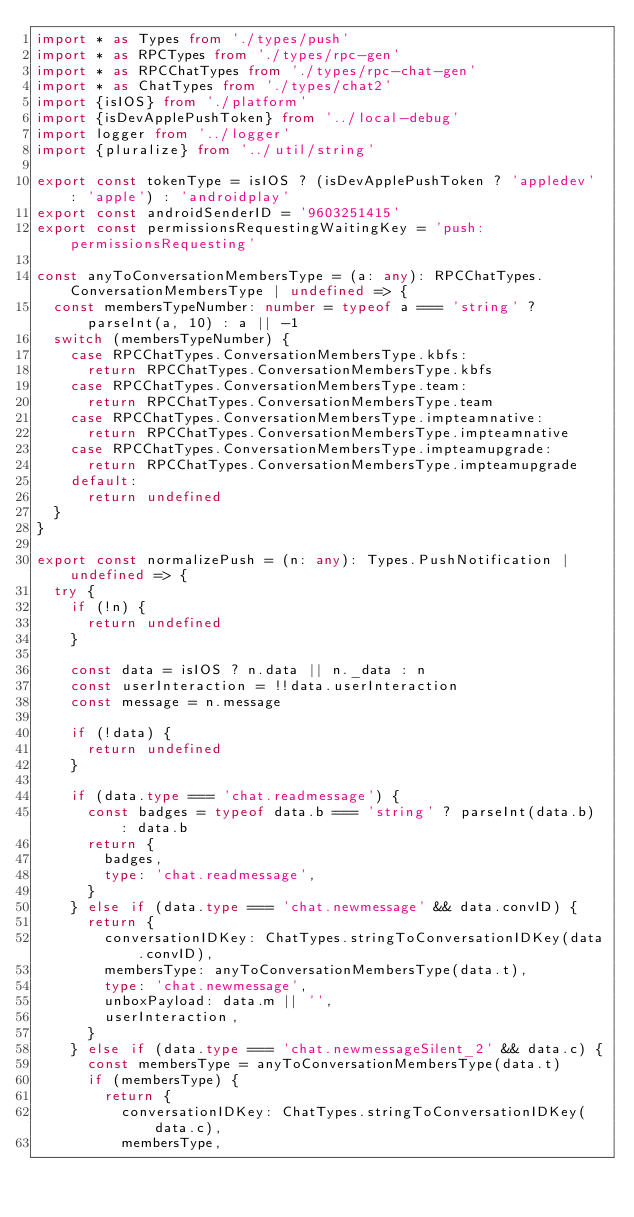<code> <loc_0><loc_0><loc_500><loc_500><_TypeScript_>import * as Types from './types/push'
import * as RPCTypes from './types/rpc-gen'
import * as RPCChatTypes from './types/rpc-chat-gen'
import * as ChatTypes from './types/chat2'
import {isIOS} from './platform'
import {isDevApplePushToken} from '../local-debug'
import logger from '../logger'
import {pluralize} from '../util/string'

export const tokenType = isIOS ? (isDevApplePushToken ? 'appledev' : 'apple') : 'androidplay'
export const androidSenderID = '9603251415'
export const permissionsRequestingWaitingKey = 'push:permissionsRequesting'

const anyToConversationMembersType = (a: any): RPCChatTypes.ConversationMembersType | undefined => {
  const membersTypeNumber: number = typeof a === 'string' ? parseInt(a, 10) : a || -1
  switch (membersTypeNumber) {
    case RPCChatTypes.ConversationMembersType.kbfs:
      return RPCChatTypes.ConversationMembersType.kbfs
    case RPCChatTypes.ConversationMembersType.team:
      return RPCChatTypes.ConversationMembersType.team
    case RPCChatTypes.ConversationMembersType.impteamnative:
      return RPCChatTypes.ConversationMembersType.impteamnative
    case RPCChatTypes.ConversationMembersType.impteamupgrade:
      return RPCChatTypes.ConversationMembersType.impteamupgrade
    default:
      return undefined
  }
}

export const normalizePush = (n: any): Types.PushNotification | undefined => {
  try {
    if (!n) {
      return undefined
    }

    const data = isIOS ? n.data || n._data : n
    const userInteraction = !!data.userInteraction
    const message = n.message

    if (!data) {
      return undefined
    }

    if (data.type === 'chat.readmessage') {
      const badges = typeof data.b === 'string' ? parseInt(data.b) : data.b
      return {
        badges,
        type: 'chat.readmessage',
      }
    } else if (data.type === 'chat.newmessage' && data.convID) {
      return {
        conversationIDKey: ChatTypes.stringToConversationIDKey(data.convID),
        membersType: anyToConversationMembersType(data.t),
        type: 'chat.newmessage',
        unboxPayload: data.m || '',
        userInteraction,
      }
    } else if (data.type === 'chat.newmessageSilent_2' && data.c) {
      const membersType = anyToConversationMembersType(data.t)
      if (membersType) {
        return {
          conversationIDKey: ChatTypes.stringToConversationIDKey(data.c),
          membersType,</code> 